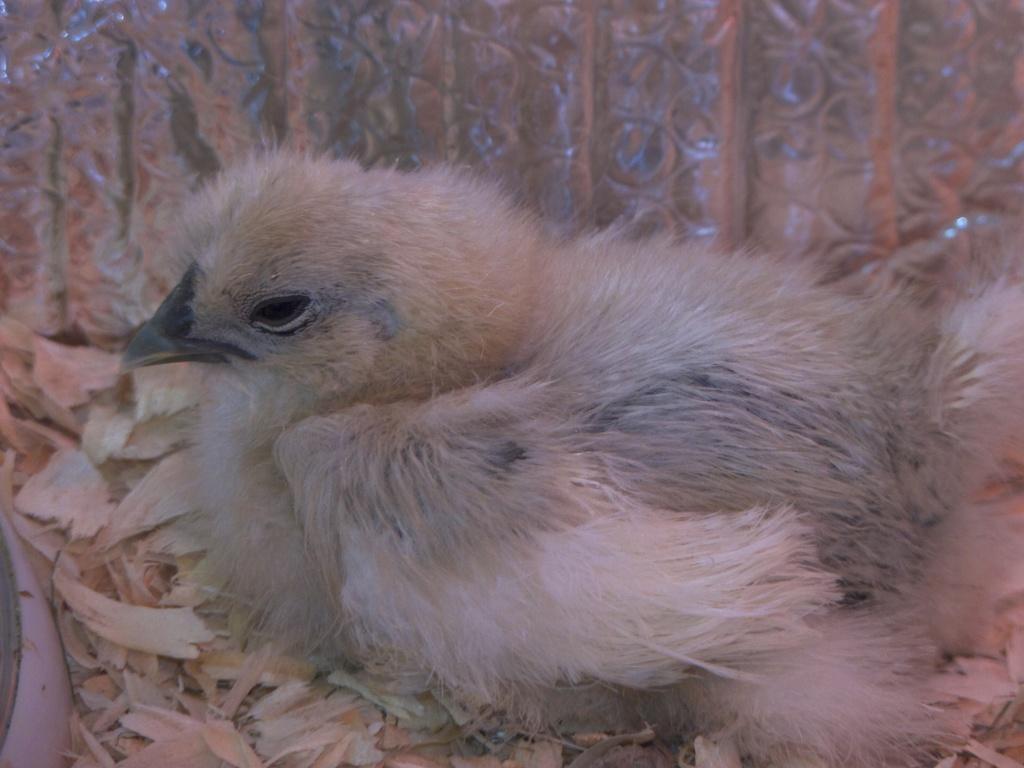How would you summarize this image in a sentence or two? In this image we can see a bird on the surface. 